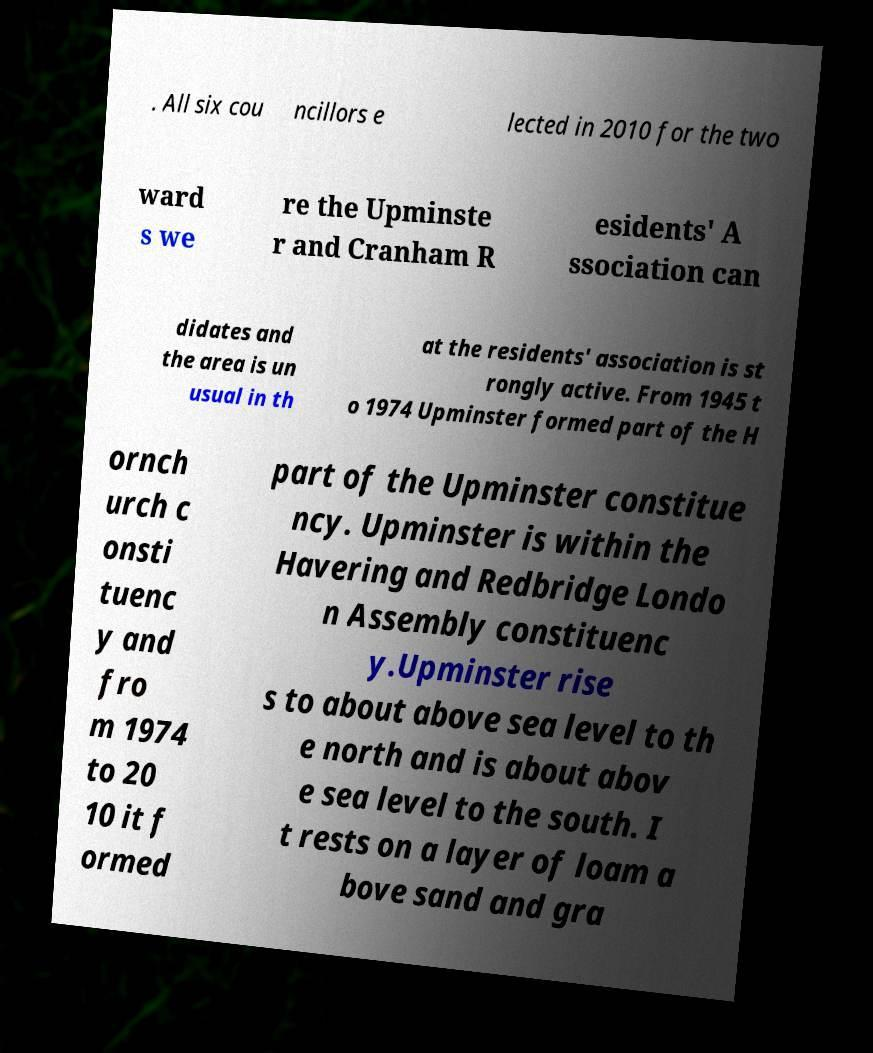Please identify and transcribe the text found in this image. . All six cou ncillors e lected in 2010 for the two ward s we re the Upminste r and Cranham R esidents' A ssociation can didates and the area is un usual in th at the residents' association is st rongly active. From 1945 t o 1974 Upminster formed part of the H ornch urch c onsti tuenc y and fro m 1974 to 20 10 it f ormed part of the Upminster constitue ncy. Upminster is within the Havering and Redbridge Londo n Assembly constituenc y.Upminster rise s to about above sea level to th e north and is about abov e sea level to the south. I t rests on a layer of loam a bove sand and gra 